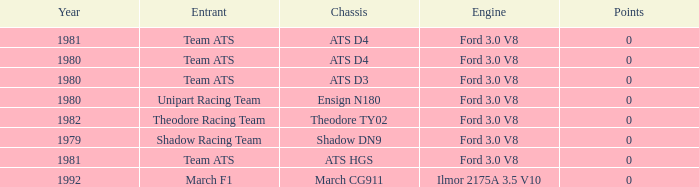What was the lowest year that the engine Ilmor 2175a 3.5 v10 was used? 1992.0. 